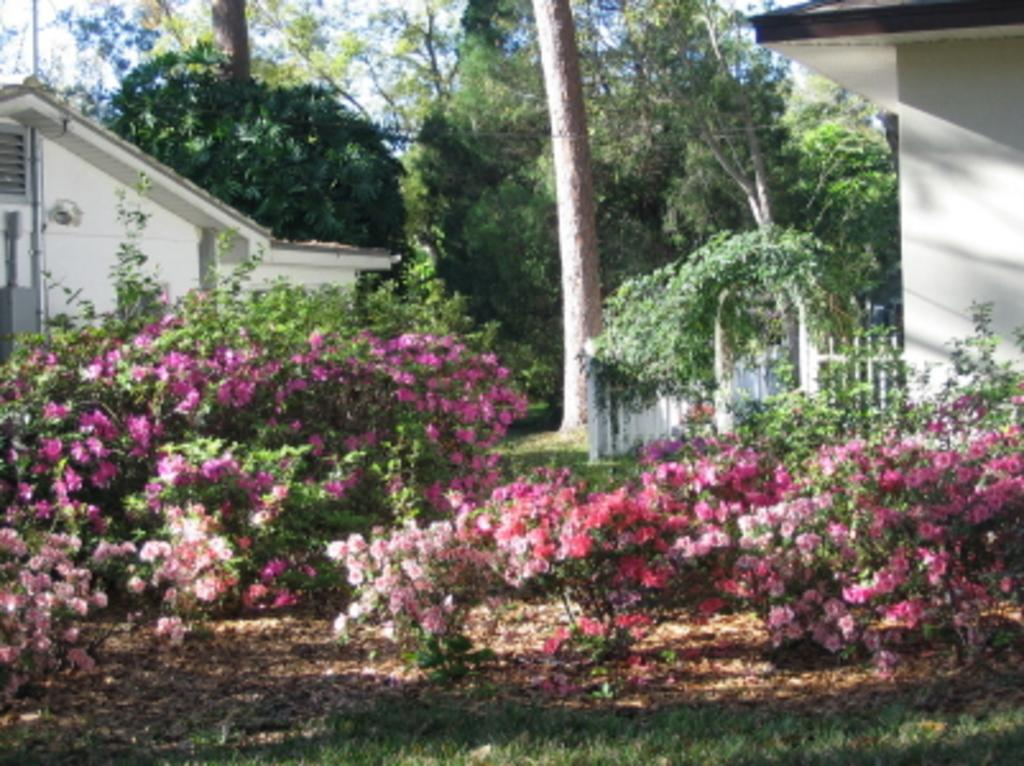What type of plants can be seen in the image? There are plants with flowers in the image. What is on the ground in the image? There is grass on the ground in the image. What type of structures are visible in the image? There are houses in the image. What type of barrier is present in the image? There is a fence in the image. What other type of vegetation is present in the image? There are trees in the image. What can be seen in the background of the image? The sky is visible in the background of the image. Where is the bottle located in the image? There is no bottle present in the image. What type of creature is shown interacting with the hydrant on the right side of the image? There is no hydrant or creature present in the image. 